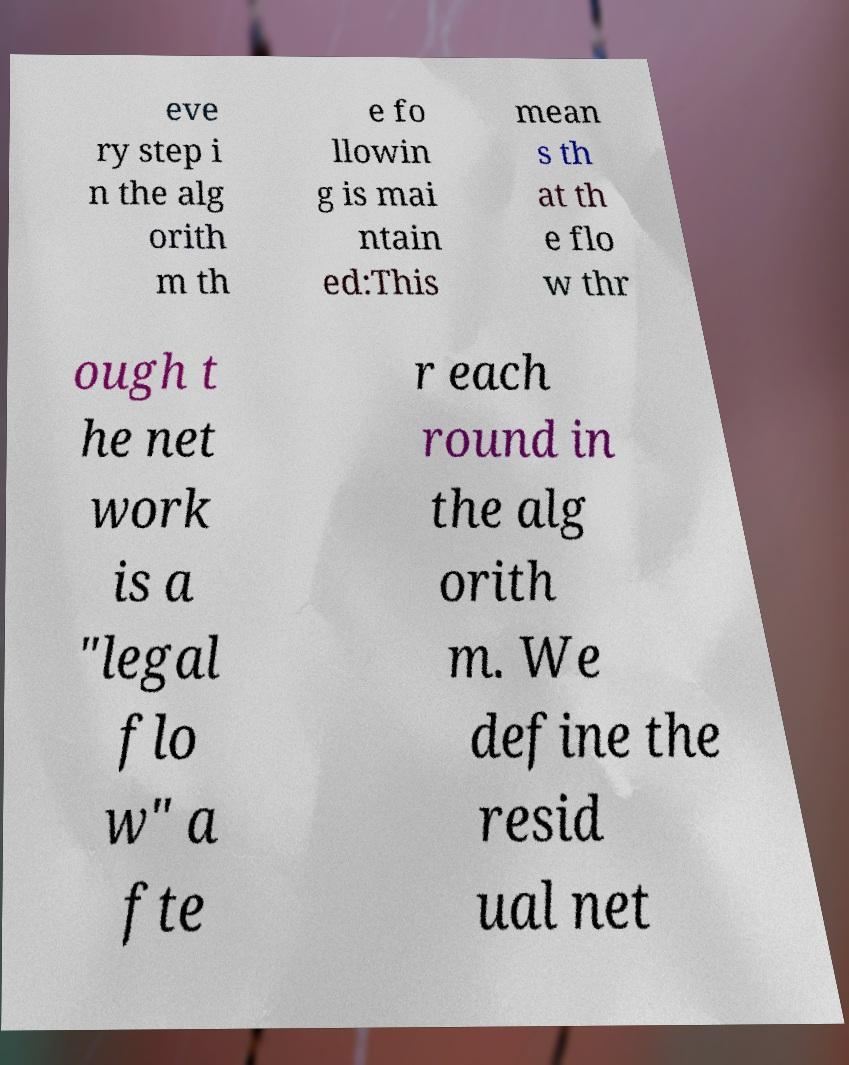For documentation purposes, I need the text within this image transcribed. Could you provide that? eve ry step i n the alg orith m th e fo llowin g is mai ntain ed:This mean s th at th e flo w thr ough t he net work is a "legal flo w" a fte r each round in the alg orith m. We define the resid ual net 